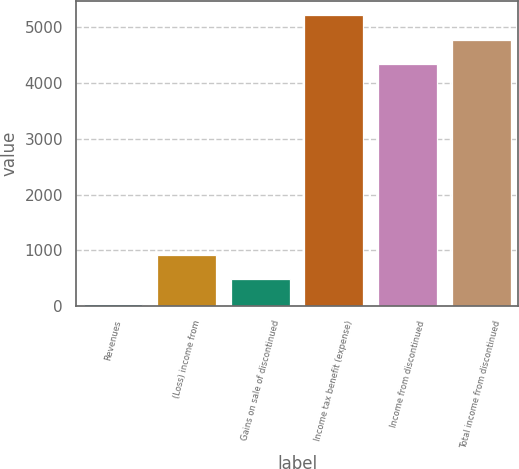Convert chart. <chart><loc_0><loc_0><loc_500><loc_500><bar_chart><fcel>Revenues<fcel>(Loss) income from<fcel>Gains on sale of discontinued<fcel>Income tax benefit (expense)<fcel>Income from discontinued<fcel>Total income from discontinued<nl><fcel>44<fcel>919.6<fcel>481.8<fcel>5210.6<fcel>4335<fcel>4772.8<nl></chart> 